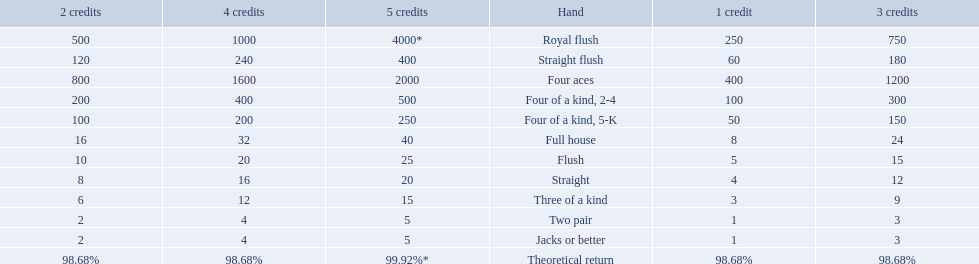What are the different hands? Royal flush, Straight flush, Four aces, Four of a kind, 2-4, Four of a kind, 5-K, Full house, Flush, Straight, Three of a kind, Two pair, Jacks or better. Which hands have a higher standing than a straight? Royal flush, Straight flush, Four aces, Four of a kind, 2-4, Four of a kind, 5-K, Full house, Flush. Of these, which hand is the next highest after a straight? Flush. 